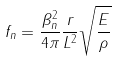Convert formula to latex. <formula><loc_0><loc_0><loc_500><loc_500>f _ { n } & = \frac { \beta _ { n } ^ { 2 } } { 4 \pi } \frac { r } { L ^ { 2 } } \sqrt { \frac { E } { \rho } }</formula> 